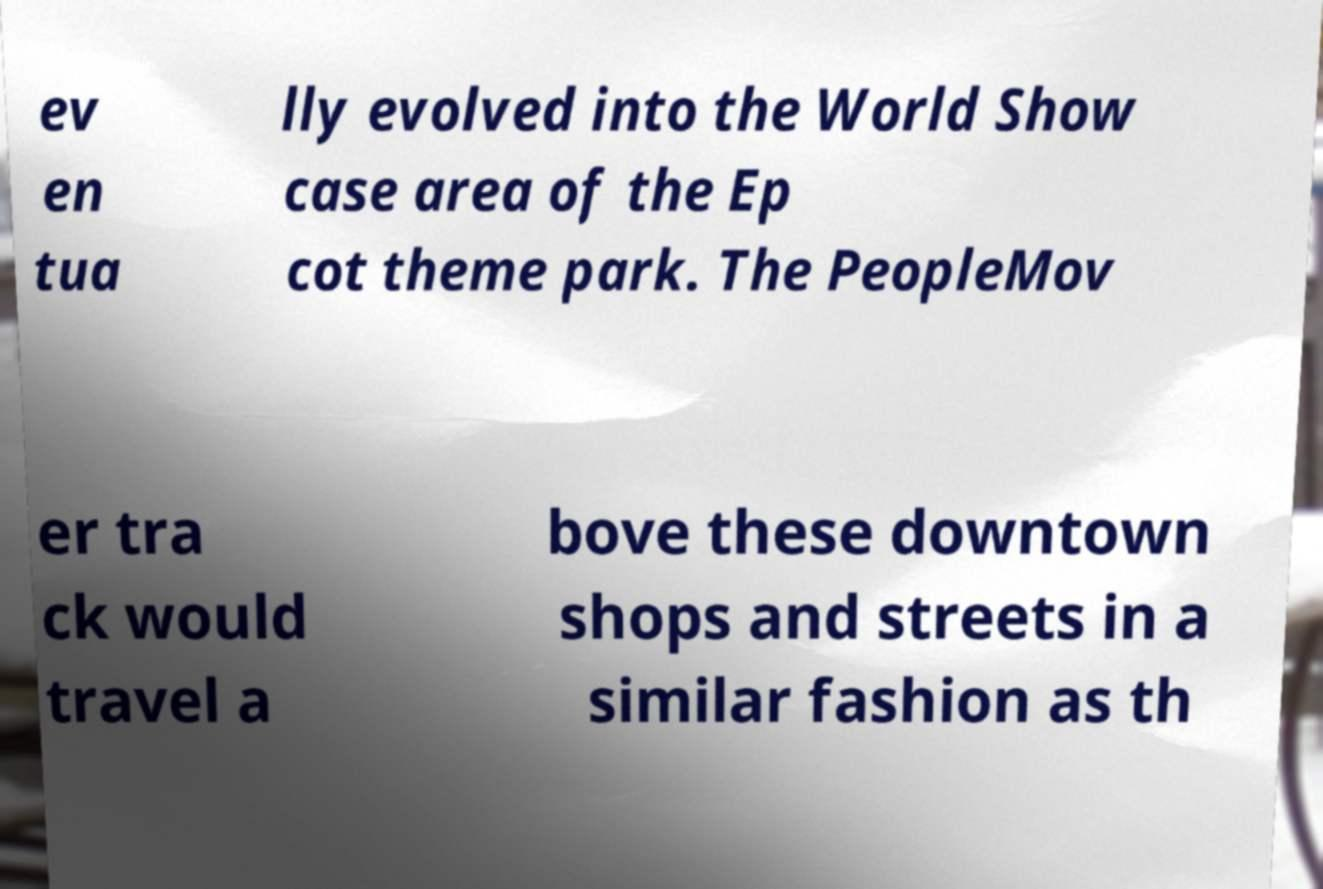Could you assist in decoding the text presented in this image and type it out clearly? ev en tua lly evolved into the World Show case area of the Ep cot theme park. The PeopleMov er tra ck would travel a bove these downtown shops and streets in a similar fashion as th 